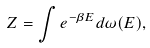<formula> <loc_0><loc_0><loc_500><loc_500>Z = \int e ^ { - \beta E } d \omega ( E ) ,</formula> 